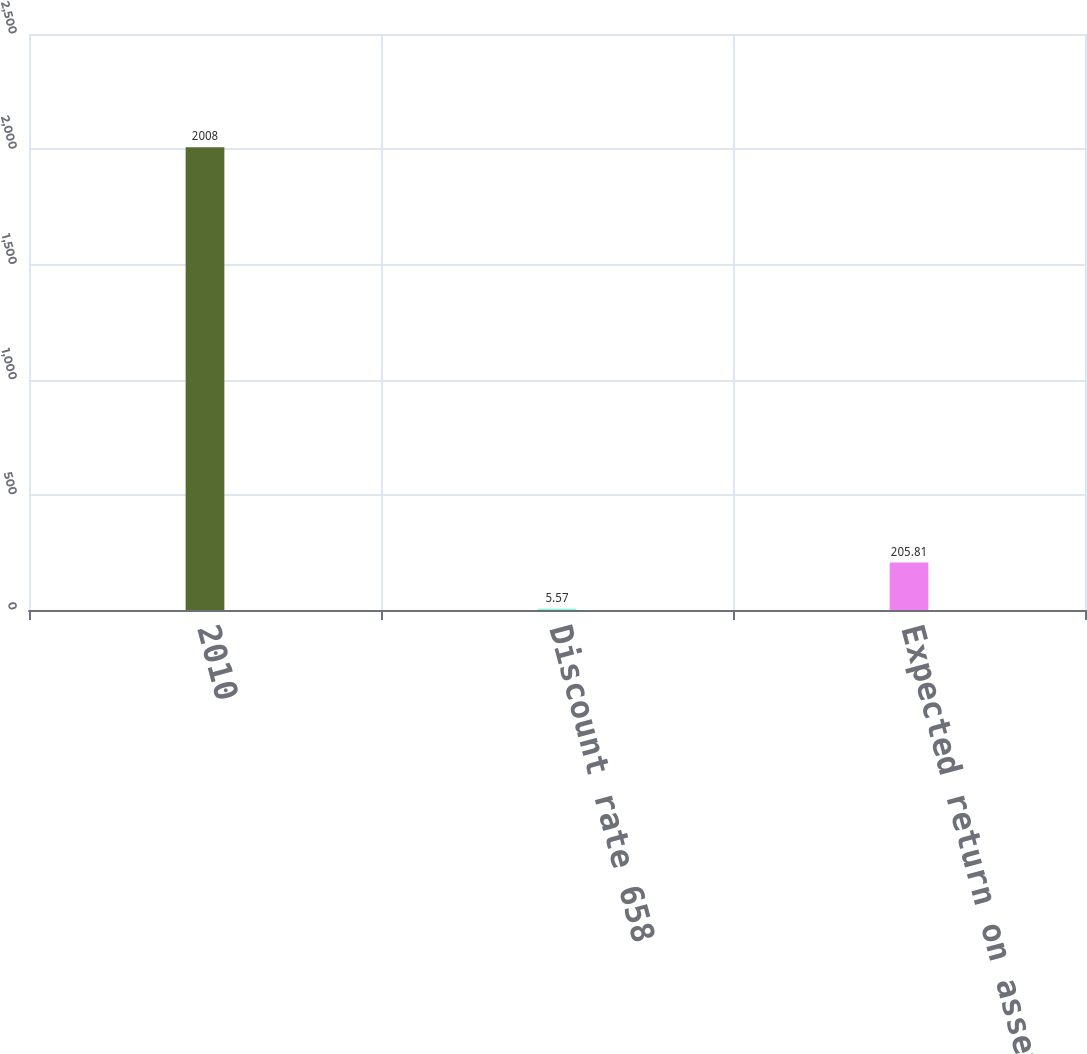<chart> <loc_0><loc_0><loc_500><loc_500><bar_chart><fcel>2010<fcel>Discount rate 658<fcel>Expected return on assets 875<nl><fcel>2008<fcel>5.57<fcel>205.81<nl></chart> 